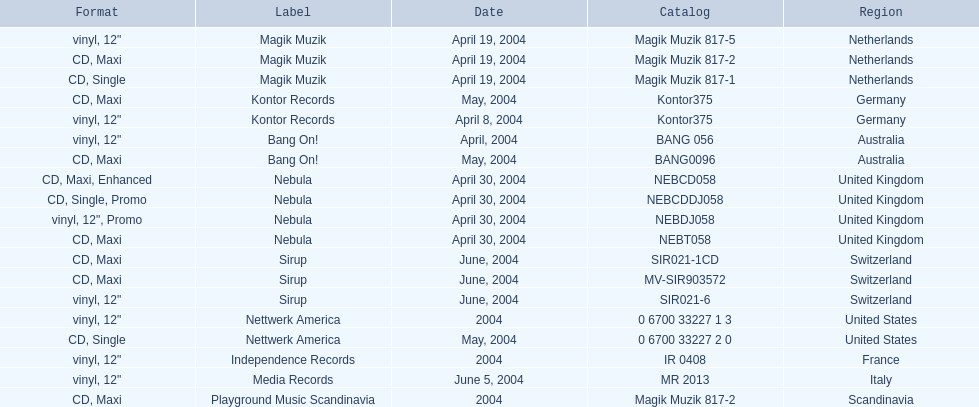What region was on the label sirup? Switzerland. Give me the full table as a dictionary. {'header': ['Format', 'Label', 'Date', 'Catalog', 'Region'], 'rows': [['vinyl, 12"', 'Magik Muzik', 'April 19, 2004', 'Magik Muzik 817-5', 'Netherlands'], ['CD, Maxi', 'Magik Muzik', 'April 19, 2004', 'Magik Muzik 817-2', 'Netherlands'], ['CD, Single', 'Magik Muzik', 'April 19, 2004', 'Magik Muzik 817-1', 'Netherlands'], ['CD, Maxi', 'Kontor Records', 'May, 2004', 'Kontor375', 'Germany'], ['vinyl, 12"', 'Kontor Records', 'April 8, 2004', 'Kontor375', 'Germany'], ['vinyl, 12"', 'Bang On!', 'April, 2004', 'BANG 056', 'Australia'], ['CD, Maxi', 'Bang On!', 'May, 2004', 'BANG0096', 'Australia'], ['CD, Maxi, Enhanced', 'Nebula', 'April 30, 2004', 'NEBCD058', 'United Kingdom'], ['CD, Single, Promo', 'Nebula', 'April 30, 2004', 'NEBCDDJ058', 'United Kingdom'], ['vinyl, 12", Promo', 'Nebula', 'April 30, 2004', 'NEBDJ058', 'United Kingdom'], ['CD, Maxi', 'Nebula', 'April 30, 2004', 'NEBT058', 'United Kingdom'], ['CD, Maxi', 'Sirup', 'June, 2004', 'SIR021-1CD', 'Switzerland'], ['CD, Maxi', 'Sirup', 'June, 2004', 'MV-SIR903572', 'Switzerland'], ['vinyl, 12"', 'Sirup', 'June, 2004', 'SIR021-6', 'Switzerland'], ['vinyl, 12"', 'Nettwerk America', '2004', '0 6700 33227 1 3', 'United States'], ['CD, Single', 'Nettwerk America', 'May, 2004', '0 6700 33227 2 0', 'United States'], ['vinyl, 12"', 'Independence Records', '2004', 'IR 0408', 'France'], ['vinyl, 12"', 'Media Records', 'June 5, 2004', 'MR 2013', 'Italy'], ['CD, Maxi', 'Playground Music Scandinavia', '2004', 'Magik Muzik 817-2', 'Scandinavia']]} 